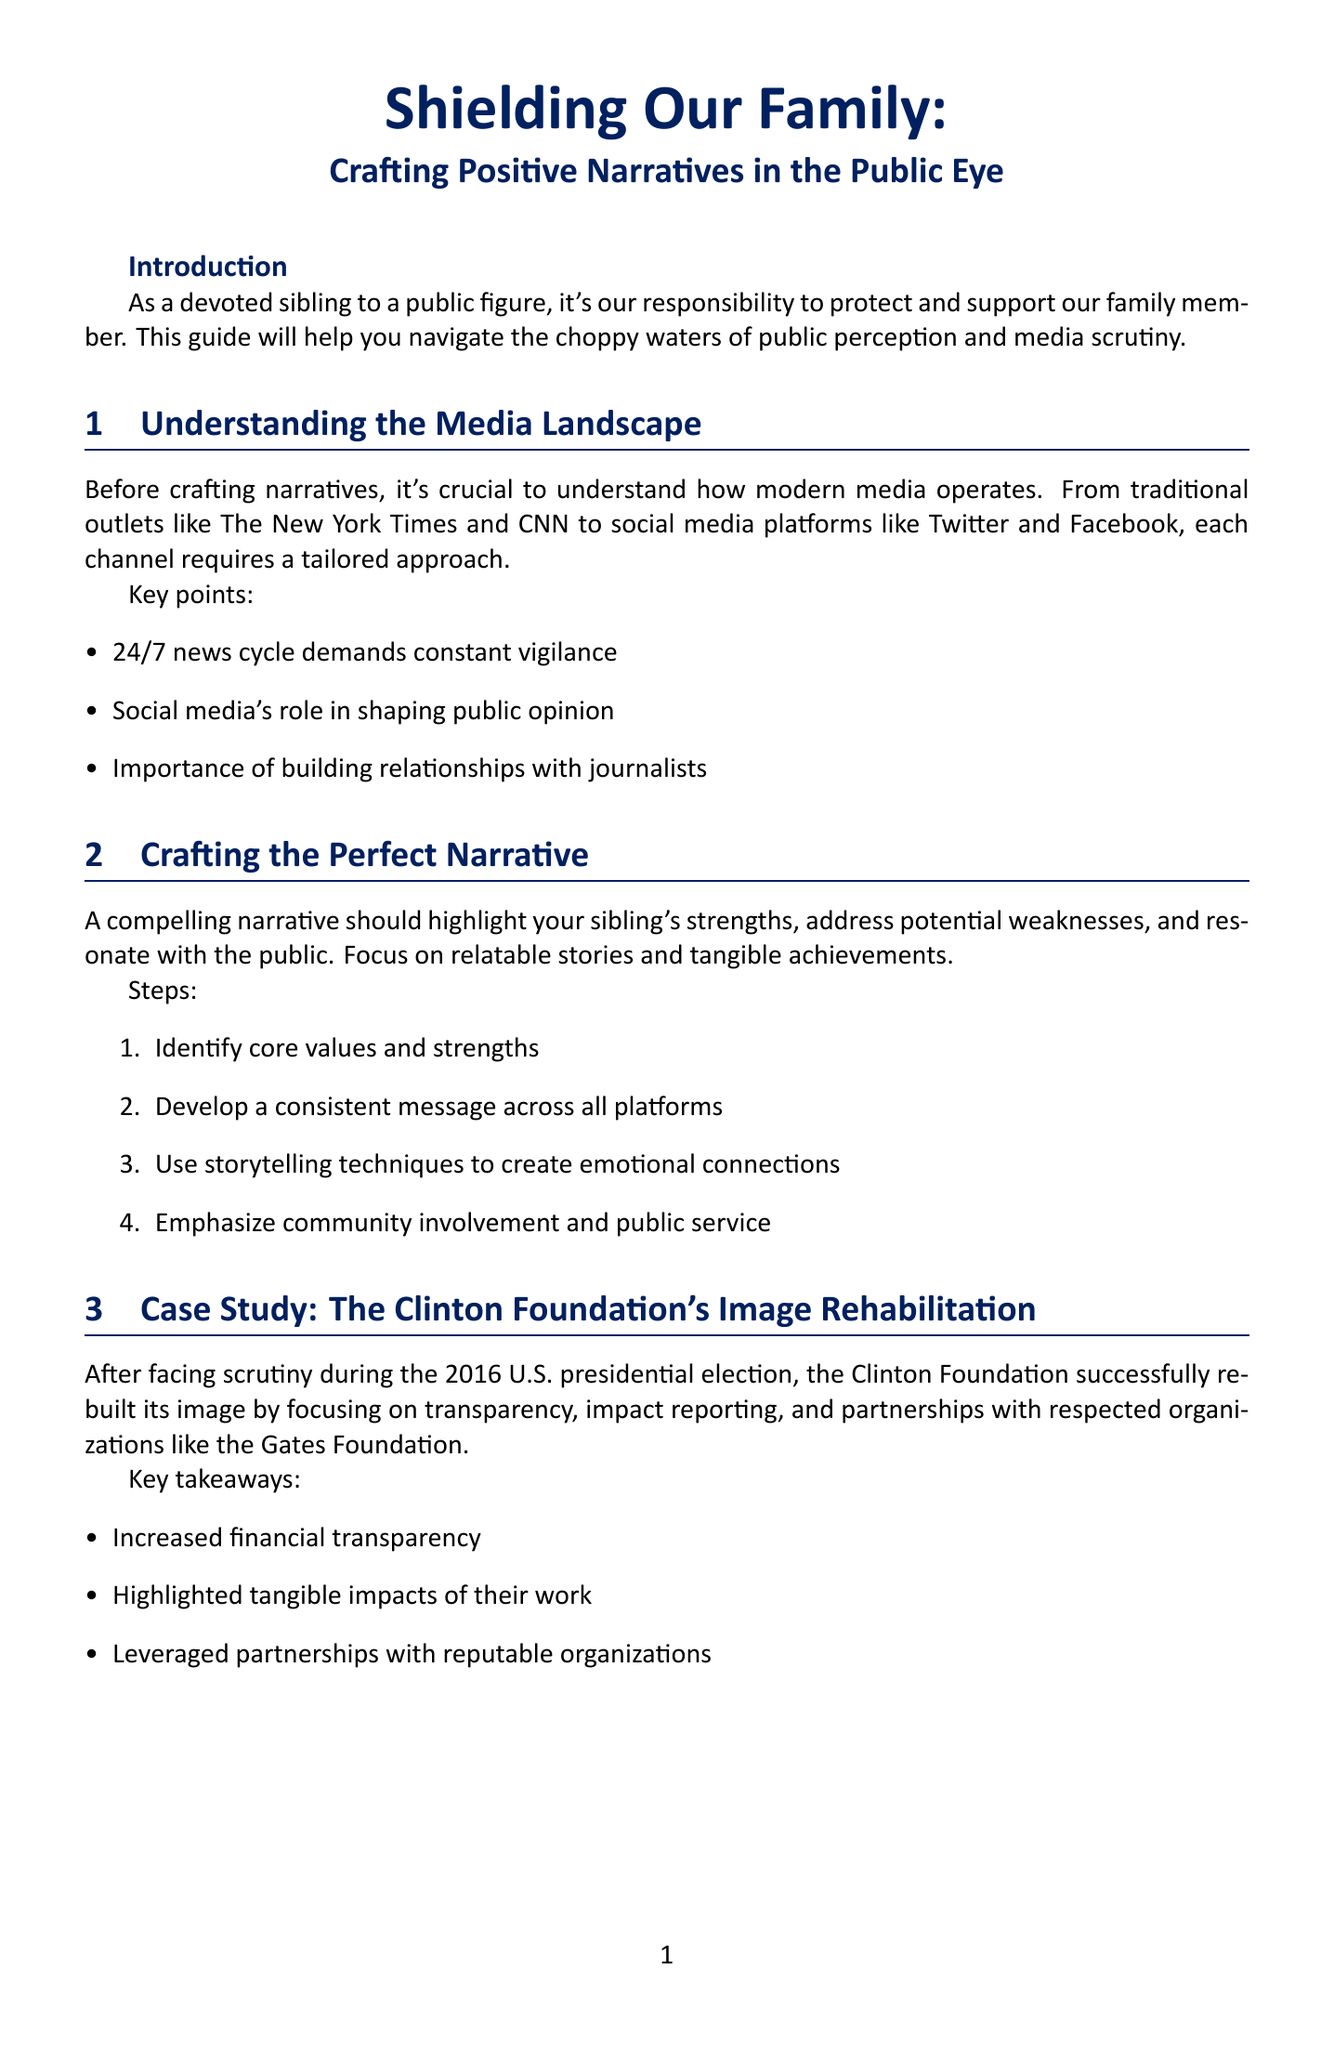What is the title of the newsletter? The title appears at the beginning of the document and is the main subject of the newsletter.
Answer: Shielding Our Family: Crafting Positive Narratives in the Public Eye What is one key point under "Understanding the Media Landscape"? This section lists several key points pertinent to media operations and public perception.
Answer: Social media's role in shaping public opinion What step is suggested for crafting the perfect narrative? The document outlines steps essential for creating a compelling narrative for a public figure.
Answer: Identify core values and strengths How did the Clinton Foundation rebuild its image? The document provides a case study with specific strategies used for image rehabilitation.
Answer: Increased financial transparency What is one technique for crisis management mentioned? The crisis management section outlines methods to address negative press effectively.
Answer: Acknowledge the issue promptly Which actor's comeback is discussed as a case study? This section provides an example of someone who successfully rehabilitated their public image.
Answer: Robert Downey Jr What is one digital tool suggested for image management? The newsletter lists various tools and platforms that can help shape public narratives.
Answer: Social media management platforms What is mentioned as a member of the support network? The document defines important allies necessary for managing public image.
Answer: PR professionals with political experience 